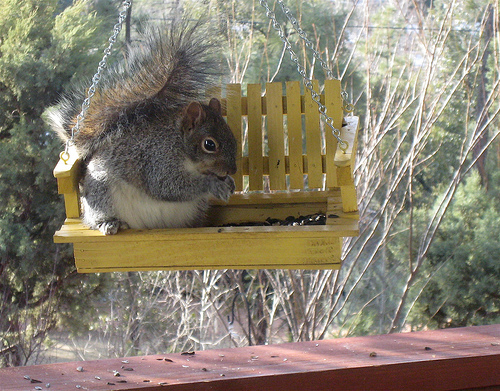<image>
Can you confirm if the squirrel is in the tree? No. The squirrel is not contained within the tree. These objects have a different spatial relationship. 